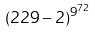Convert formula to latex. <formula><loc_0><loc_0><loc_500><loc_500>( 2 2 9 - 2 ) ^ { 9 ^ { 7 2 } }</formula> 